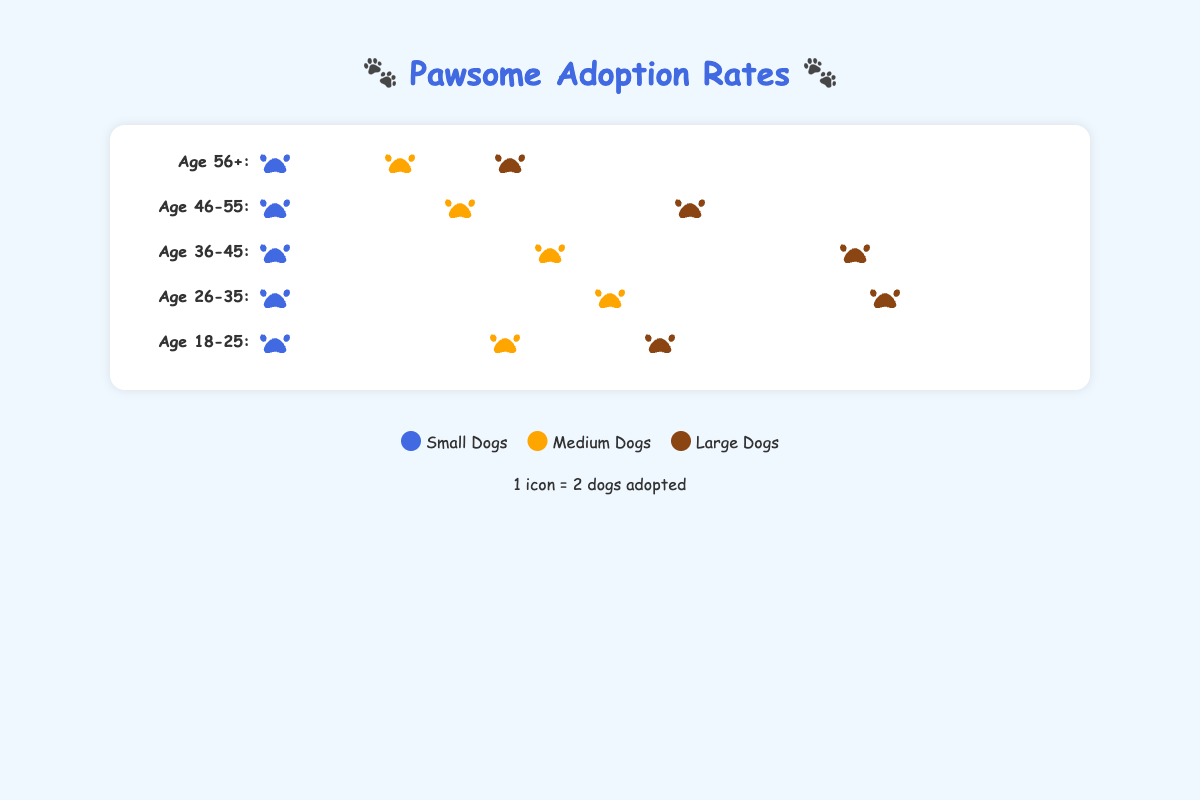How many icons represent the adoption rates of small dogs for the age group 26-35? Count the number of icons representing small dogs for the age group 26-35. Each icon represents 2 dogs. There are 11 icons.
Answer: 11 Which age group has the highest adoption rate for medium dogs? Look at the icons for medium dogs and compare them across all age groups. The age group 36-45 has the highest adoption rate with 15 icons.
Answer: 36-45 What is the total number of small dogs adopted in the age group 18-25? Each icon represents 2 dogs. The age group 18-25 has 15 icons for small dogs. Multiply the number of icons by 2. Total = 15 * 2 = 30 dogs adopted.
Answer: 30 Compare the adoption rates of large dogs between the age groups 56+ and 46-55. Which age group has a higher rate? Count the number of icons representing large dogs in the age groups 56+ and 46-55. The 56+ group has 3 icons, and the 46-55 group has 8 icons. Therefore, the 46-55 group has a higher rate.
Answer: 46-55 What is the total adoption rate for medium dogs across all age groups? Add the number of adoptions for medium dogs across all age groups. The number of icons for each age group is: 18-25 (5), 26-35 (9), 36-45 (10), 46-55 (8), 56+ (4). Total = (5 + 9 + 10 + 8 + 4) * 2 = 36 * 2 = 72
Answer: 72 Which age group has the lowest overall adoption rates across all dog sizes? Sum the number of icons across all dog sizes for each age group. The age group 56+ has the lowest number of icons: Small (4), Medium (3.5), Large (1.5). = 4 + 3.5 + 1.5 = 9
Answer: 56+ How do the adoption rates of small and large dogs compare for the age group 36-45? Count the number of icons representing small and large dogs for the age group 36-45. Small dogs have 9 icons, and large dogs have 7.5 icons. Small dogs have more adoptions.
Answer: Small dogs What is the average number of dogs adopted across all sizes in the age group 26-35? Each icon represents 2 dogs. Sum the adoption rates for all sizes in the age group 26-35 and divide by 3. Small (11), Medium (9), Large (5). Total = (11 + 9 + 5) / 3 = 25 / 3 = 8.33 (rounded to 2 decimal places)
Answer: 8.33 Which dog size has the most consistent adoption rates across all age groups? Compare the number of icons for each dog size in all age groups. Medium dogs seem to have more consistent adoption rates compared to small and large dogs.
Answer: Medium 